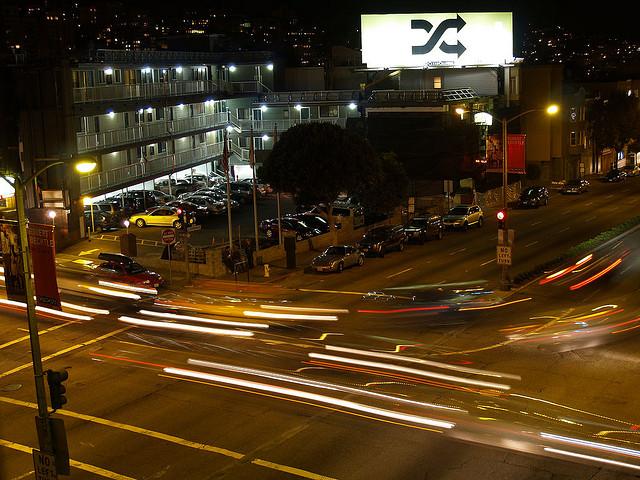Is it raining?
Write a very short answer. No. Is this a time lapse photo?
Short answer required. Yes. Do you see any lights on?
Keep it brief. Yes. How many buildings are visible?
Keep it brief. 2. 